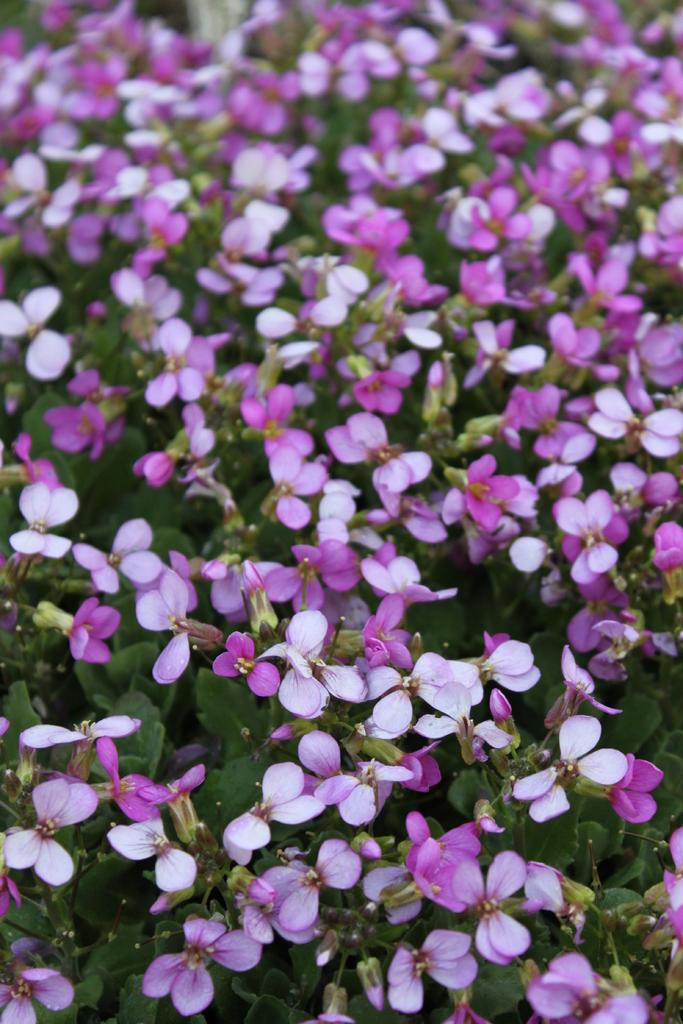What type of plant life can be seen in the image? There are flowers and leaves in the image. Can you describe the flowers in the image? Unfortunately, the facts provided do not give specific details about the flowers. What is the relationship between the flowers and leaves in the image? The flowers and leaves are likely part of the same plant or plants in the image. What type of badge is being awarded to the kettle in the image? There is no kettle or badge present in the image. What is the desire of the flowers in the image? The facts provided do not give any information about the desires of the flowers. 